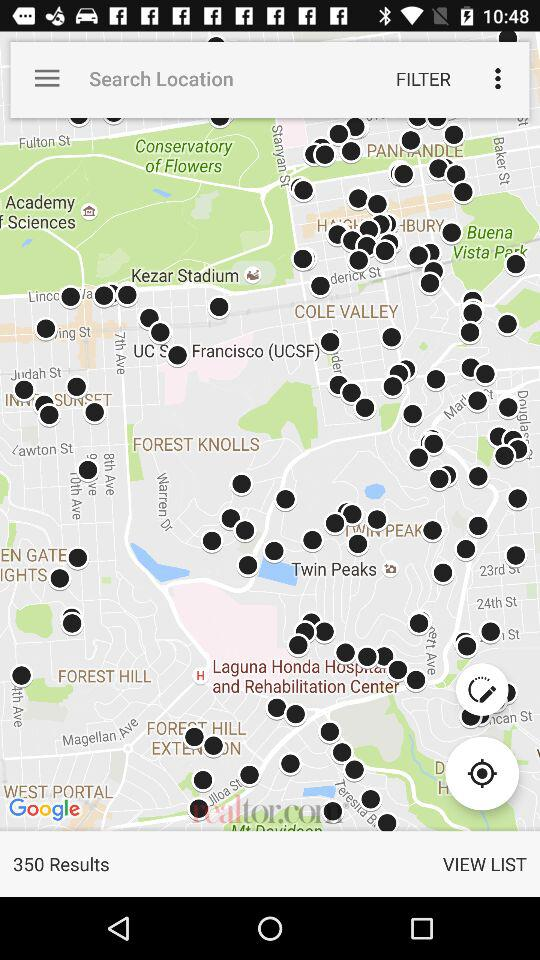How many results are shown on the map? There are 350 results shown on the map. 